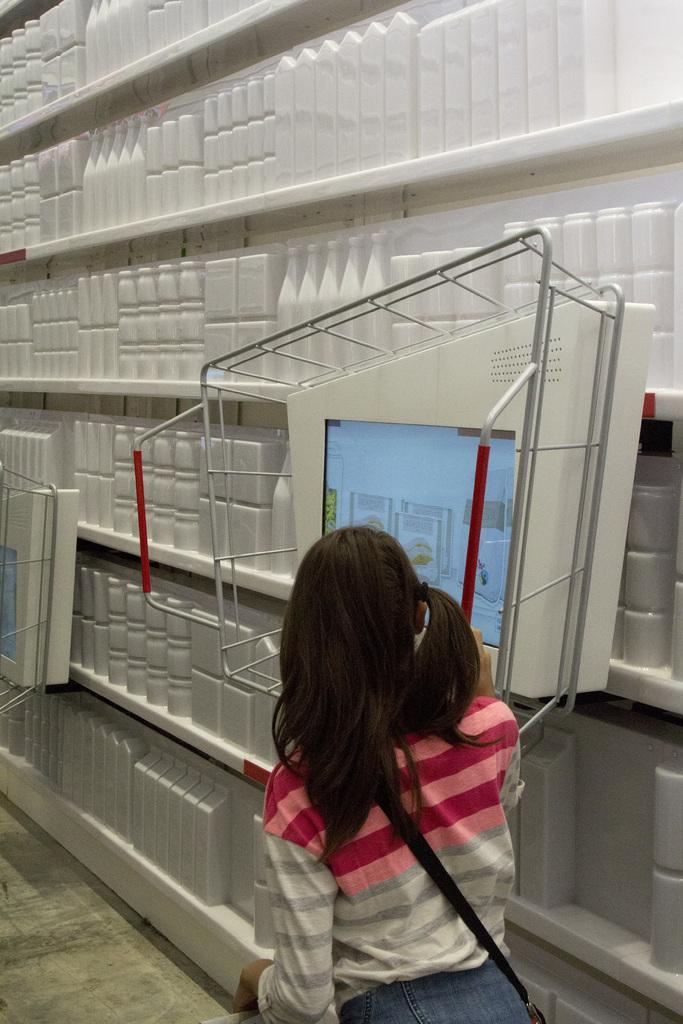Describe this image in one or two sentences. In this image we can see a person standing and in front of her there is an object which looks like a screen. There is a rack with some objects which are in white color. 